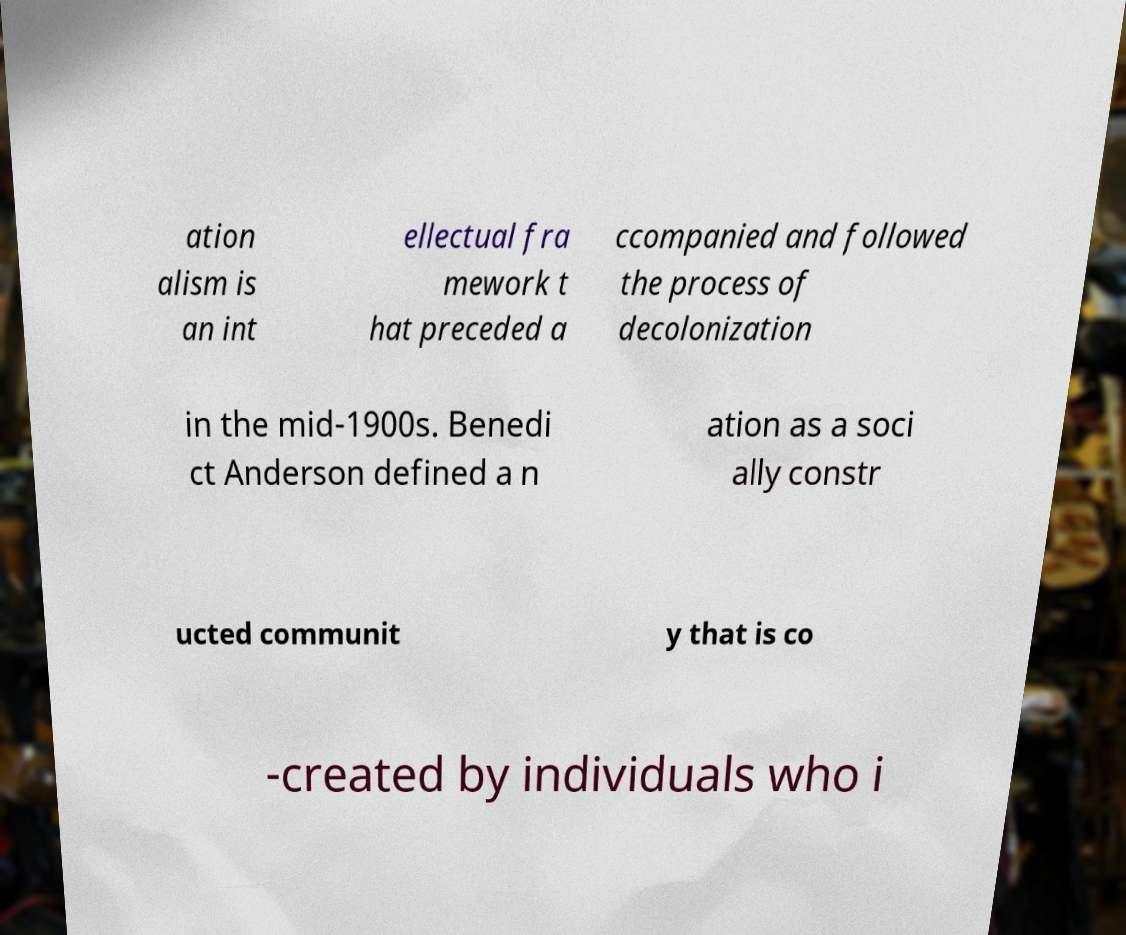Please identify and transcribe the text found in this image. ation alism is an int ellectual fra mework t hat preceded a ccompanied and followed the process of decolonization in the mid-1900s. Benedi ct Anderson defined a n ation as a soci ally constr ucted communit y that is co -created by individuals who i 